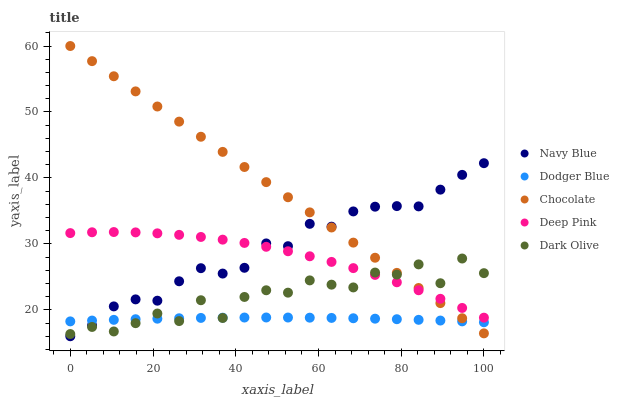Does Dodger Blue have the minimum area under the curve?
Answer yes or no. Yes. Does Chocolate have the maximum area under the curve?
Answer yes or no. Yes. Does Navy Blue have the minimum area under the curve?
Answer yes or no. No. Does Navy Blue have the maximum area under the curve?
Answer yes or no. No. Is Chocolate the smoothest?
Answer yes or no. Yes. Is Dark Olive the roughest?
Answer yes or no. Yes. Is Navy Blue the smoothest?
Answer yes or no. No. Is Navy Blue the roughest?
Answer yes or no. No. Does Navy Blue have the lowest value?
Answer yes or no. Yes. Does Deep Pink have the lowest value?
Answer yes or no. No. Does Chocolate have the highest value?
Answer yes or no. Yes. Does Navy Blue have the highest value?
Answer yes or no. No. Is Dodger Blue less than Deep Pink?
Answer yes or no. Yes. Is Deep Pink greater than Dodger Blue?
Answer yes or no. Yes. Does Chocolate intersect Dodger Blue?
Answer yes or no. Yes. Is Chocolate less than Dodger Blue?
Answer yes or no. No. Is Chocolate greater than Dodger Blue?
Answer yes or no. No. Does Dodger Blue intersect Deep Pink?
Answer yes or no. No. 